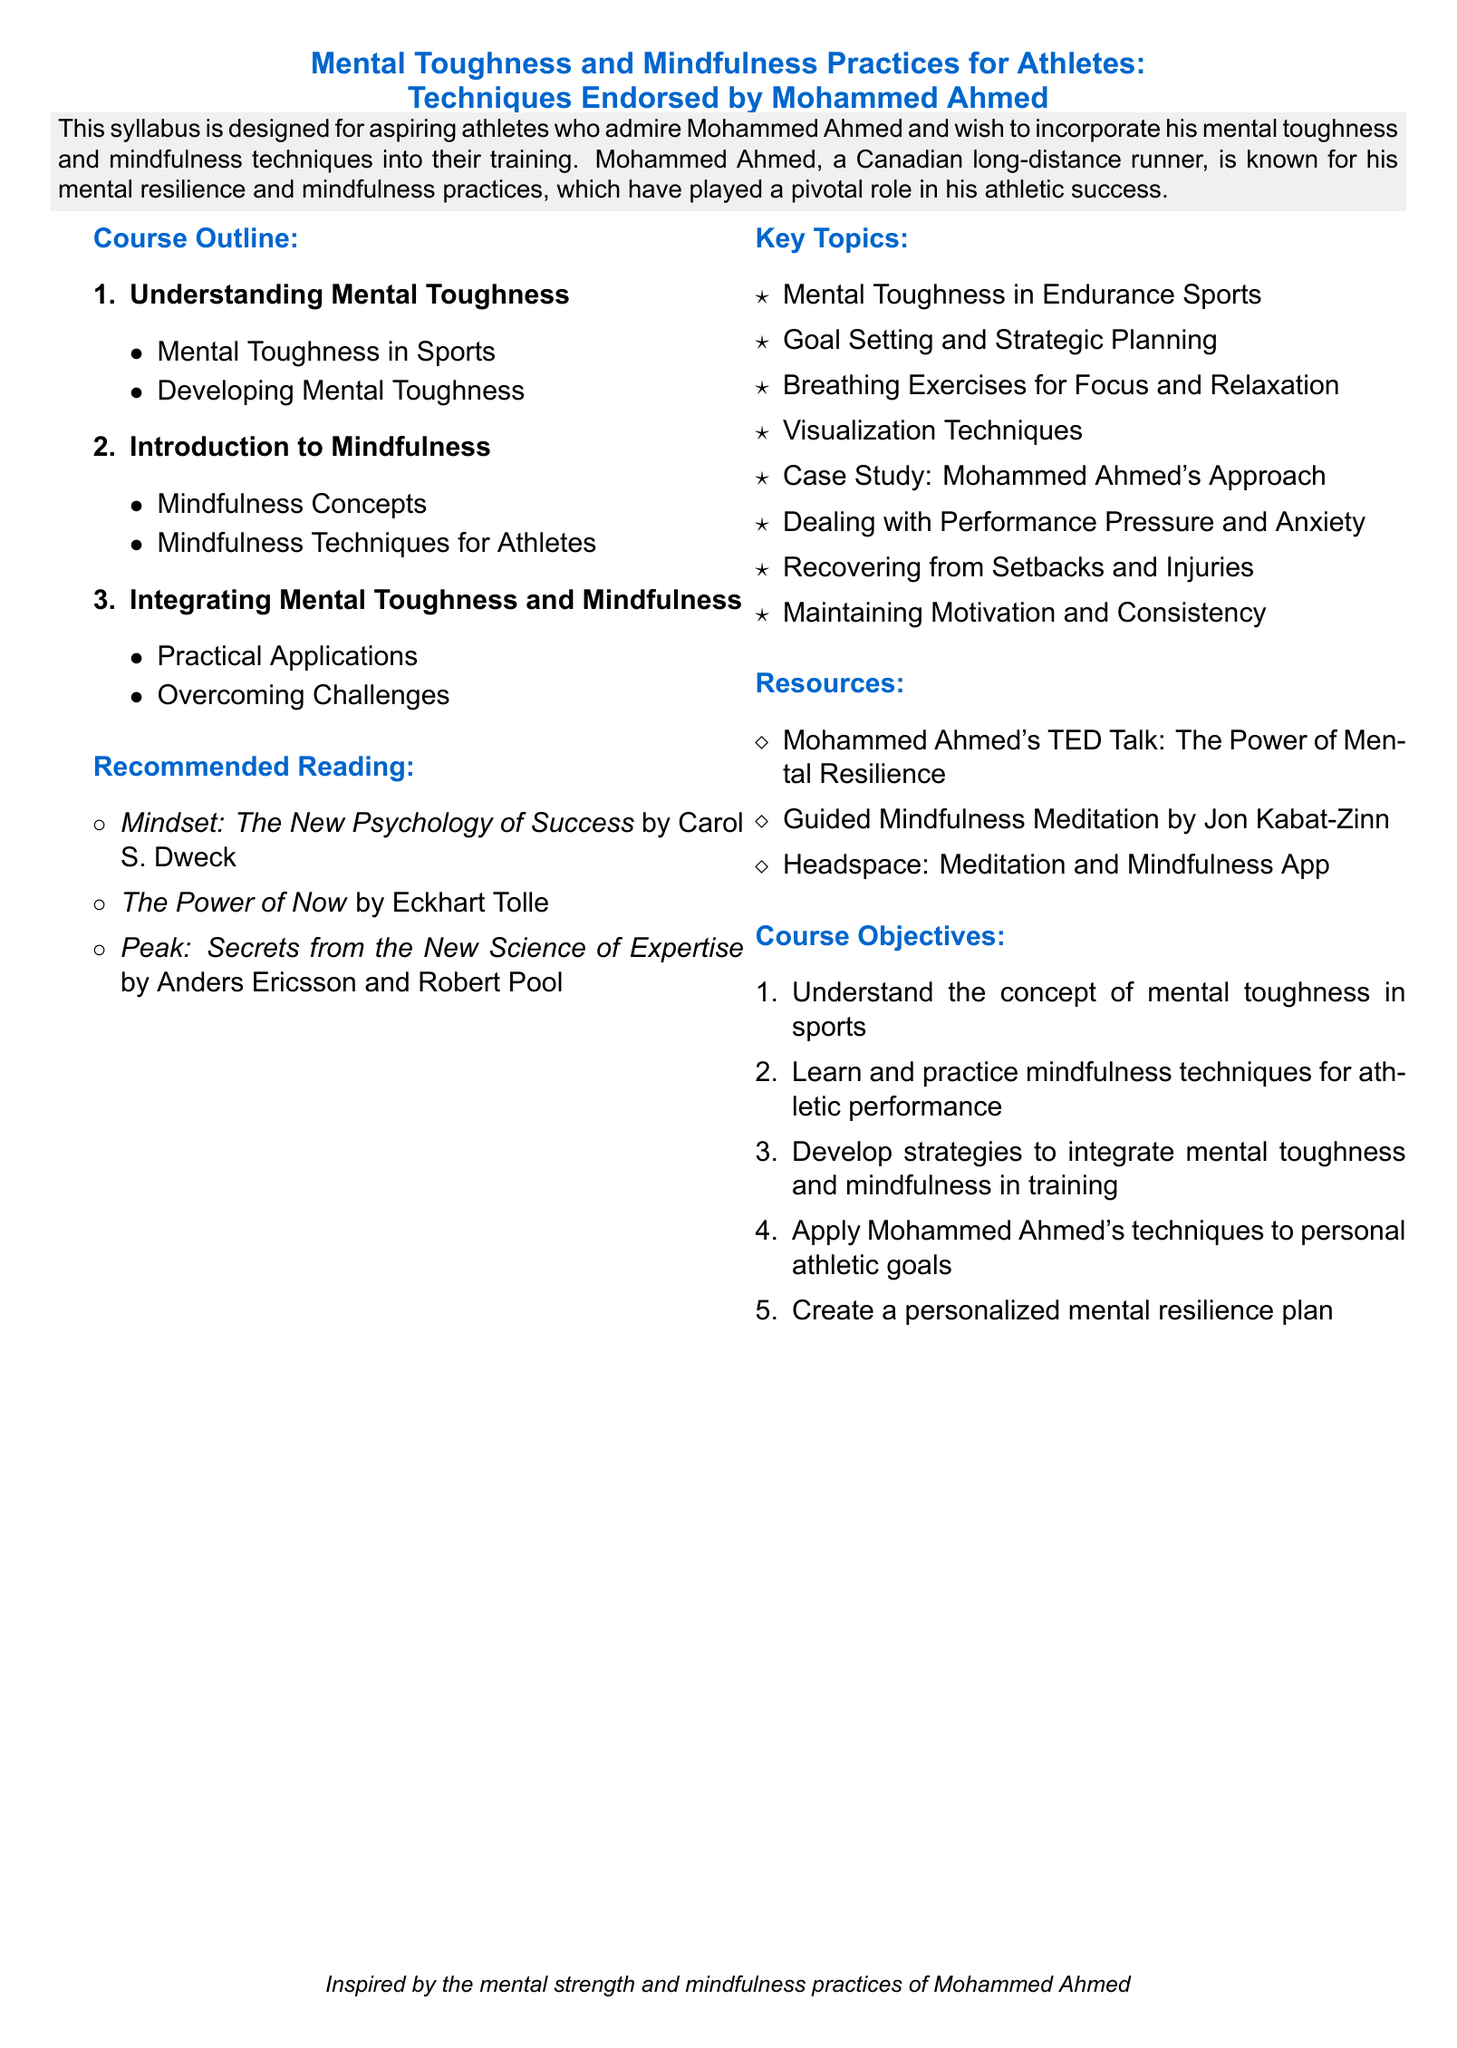What is the title of the syllabus? The title of the syllabus is stated at the beginning of the document, focusing on mental toughness and mindfulness practices for athletes.
Answer: Mental Toughness and Mindfulness Practices for Athletes: Techniques Endorsed by Mohammed Ahmed Who is the course aimed at? The document specifies that this syllabus is designed for aspiring athletes with admiration for a specific individual.
Answer: Aspiring athletes What is the first topic in the course outline? The first topic listed in the course outline addresses a key aspect of the course's main theme.
Answer: Understanding Mental Toughness Name one technique recommended for athletes. The syllabus provides a list of techniques specifically designed for athletes to improve their performance.
Answer: Breathing Exercises for Focus and Relaxation How many key topics are mentioned in the syllabus? The total number of key topics is counted from the list provided in the document.
Answer: Eight Which book is recommended reading about success? The document includes a book that discusses the psychology of success, recommended as reading material.
Answer: Mindset: The New Psychology of Success What is one resource mentioned in the syllabus? The document lists resources that can help improve mindfulness and mental toughness among athletes.
Answer: Mohammed Ahmed's TED Talk: The Power of Mental Resilience What is the main objective of the course? The document outlines specific objectives that aim to enhance understanding and application of mental toughness and mindfulness in athletics.
Answer: Understand the concept of mental toughness in sports 